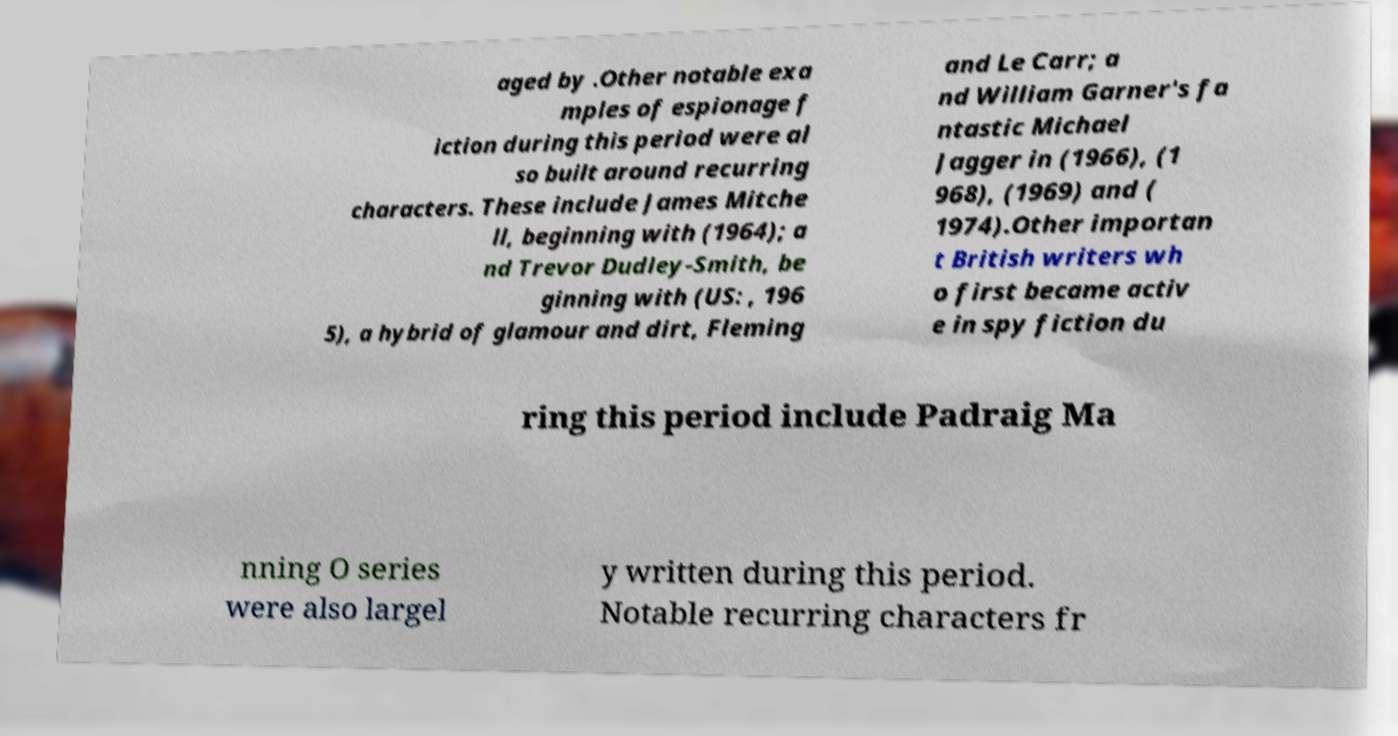Can you accurately transcribe the text from the provided image for me? aged by .Other notable exa mples of espionage f iction during this period were al so built around recurring characters. These include James Mitche ll, beginning with (1964); a nd Trevor Dudley-Smith, be ginning with (US: , 196 5), a hybrid of glamour and dirt, Fleming and Le Carr; a nd William Garner's fa ntastic Michael Jagger in (1966), (1 968), (1969) and ( 1974).Other importan t British writers wh o first became activ e in spy fiction du ring this period include Padraig Ma nning O series were also largel y written during this period. Notable recurring characters fr 